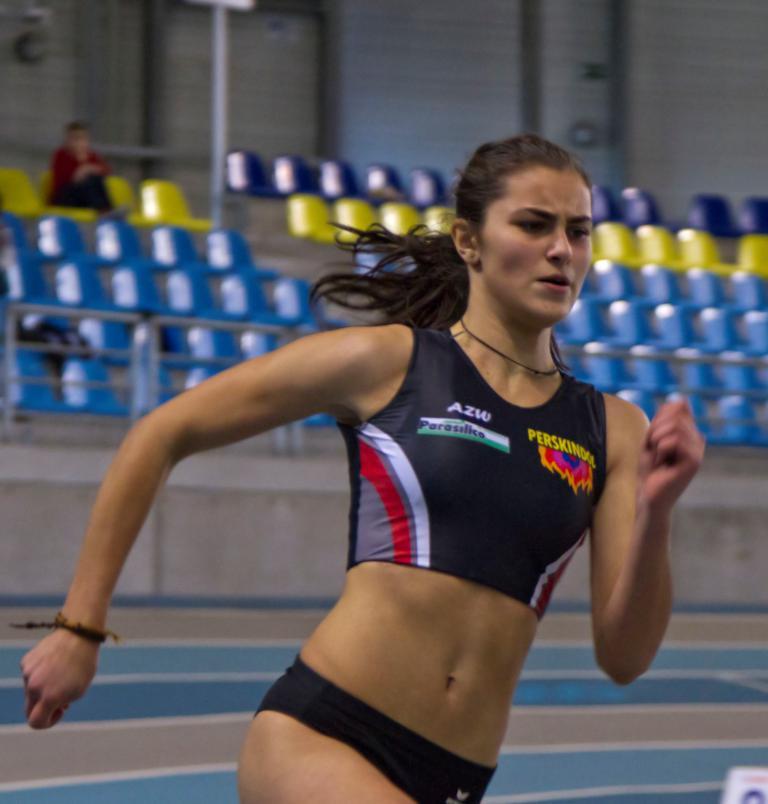What team does the girl run for?
Give a very brief answer. Azw. 